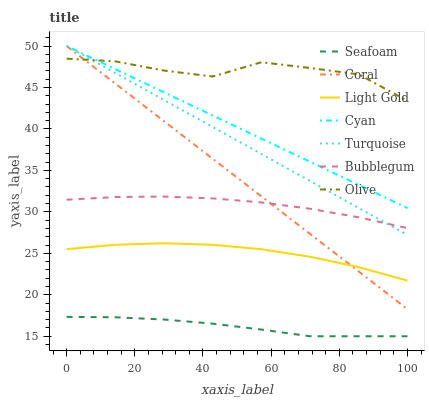Does Seafoam have the minimum area under the curve?
Answer yes or no. Yes. Does Olive have the maximum area under the curve?
Answer yes or no. Yes. Does Coral have the minimum area under the curve?
Answer yes or no. No. Does Coral have the maximum area under the curve?
Answer yes or no. No. Is Coral the smoothest?
Answer yes or no. Yes. Is Olive the roughest?
Answer yes or no. Yes. Is Seafoam the smoothest?
Answer yes or no. No. Is Seafoam the roughest?
Answer yes or no. No. Does Seafoam have the lowest value?
Answer yes or no. Yes. Does Coral have the lowest value?
Answer yes or no. No. Does Cyan have the highest value?
Answer yes or no. Yes. Does Seafoam have the highest value?
Answer yes or no. No. Is Bubblegum less than Olive?
Answer yes or no. Yes. Is Bubblegum greater than Seafoam?
Answer yes or no. Yes. Does Turquoise intersect Cyan?
Answer yes or no. Yes. Is Turquoise less than Cyan?
Answer yes or no. No. Is Turquoise greater than Cyan?
Answer yes or no. No. Does Bubblegum intersect Olive?
Answer yes or no. No. 